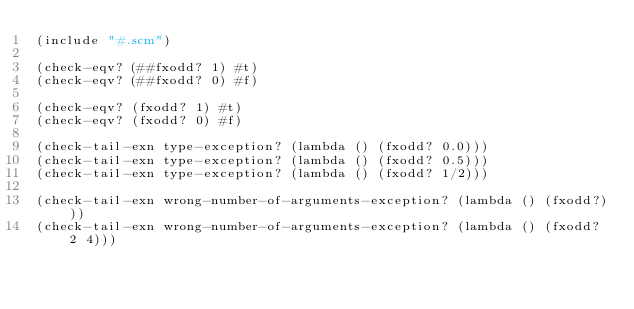Convert code to text. <code><loc_0><loc_0><loc_500><loc_500><_Scheme_>(include "#.scm")

(check-eqv? (##fxodd? 1) #t)
(check-eqv? (##fxodd? 0) #f)

(check-eqv? (fxodd? 1) #t)
(check-eqv? (fxodd? 0) #f)

(check-tail-exn type-exception? (lambda () (fxodd? 0.0)))
(check-tail-exn type-exception? (lambda () (fxodd? 0.5)))
(check-tail-exn type-exception? (lambda () (fxodd? 1/2)))

(check-tail-exn wrong-number-of-arguments-exception? (lambda () (fxodd?)))
(check-tail-exn wrong-number-of-arguments-exception? (lambda () (fxodd? 2 4)))
</code> 